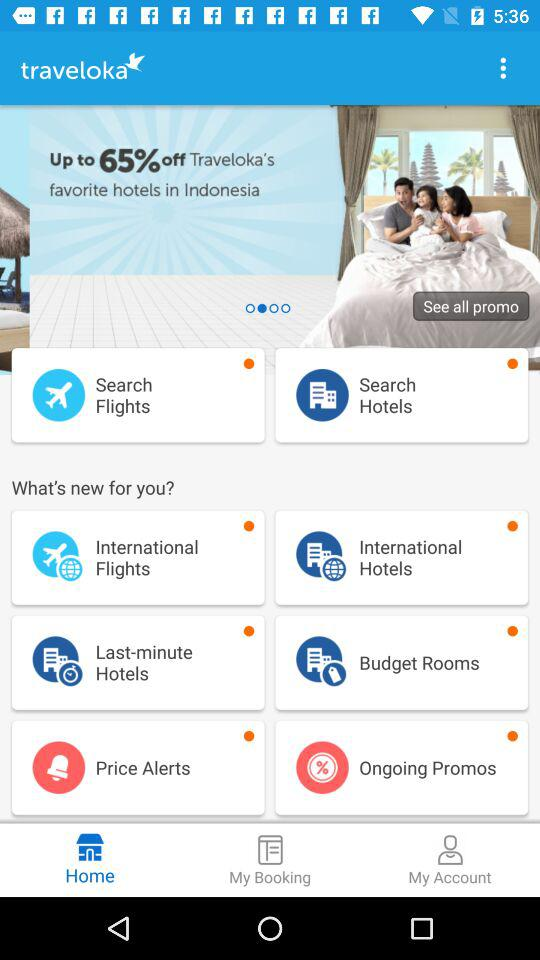How much is the discount on "traveloka"? The discount is up to 65%. 